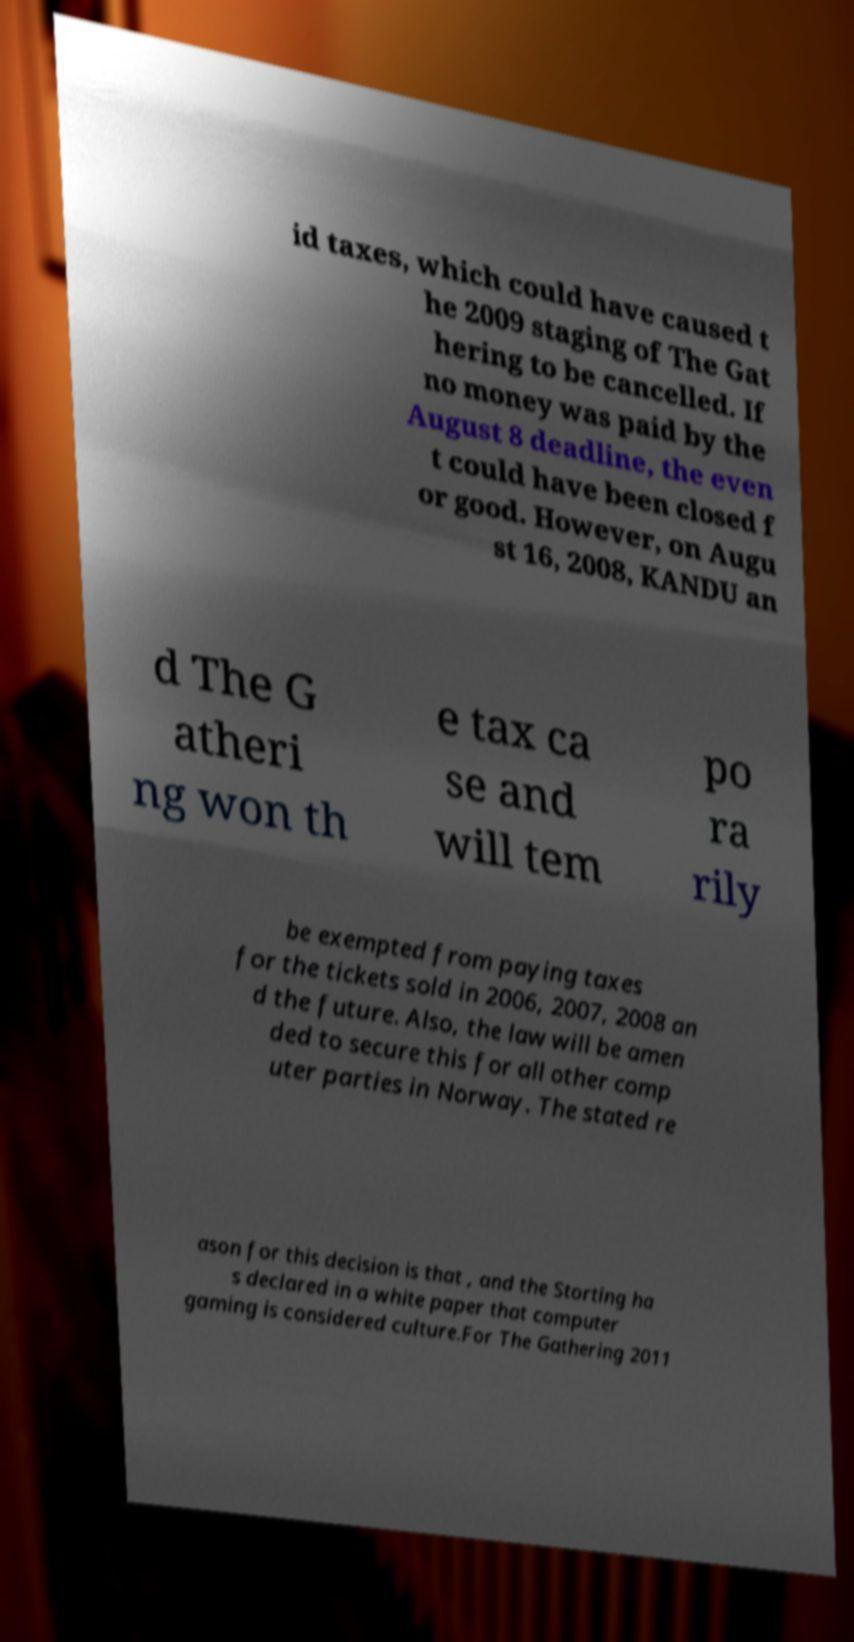What messages or text are displayed in this image? I need them in a readable, typed format. id taxes, which could have caused t he 2009 staging of The Gat hering to be cancelled. If no money was paid by the August 8 deadline, the even t could have been closed f or good. However, on Augu st 16, 2008, KANDU an d The G atheri ng won th e tax ca se and will tem po ra rily be exempted from paying taxes for the tickets sold in 2006, 2007, 2008 an d the future. Also, the law will be amen ded to secure this for all other comp uter parties in Norway. The stated re ason for this decision is that , and the Storting ha s declared in a white paper that computer gaming is considered culture.For The Gathering 2011 